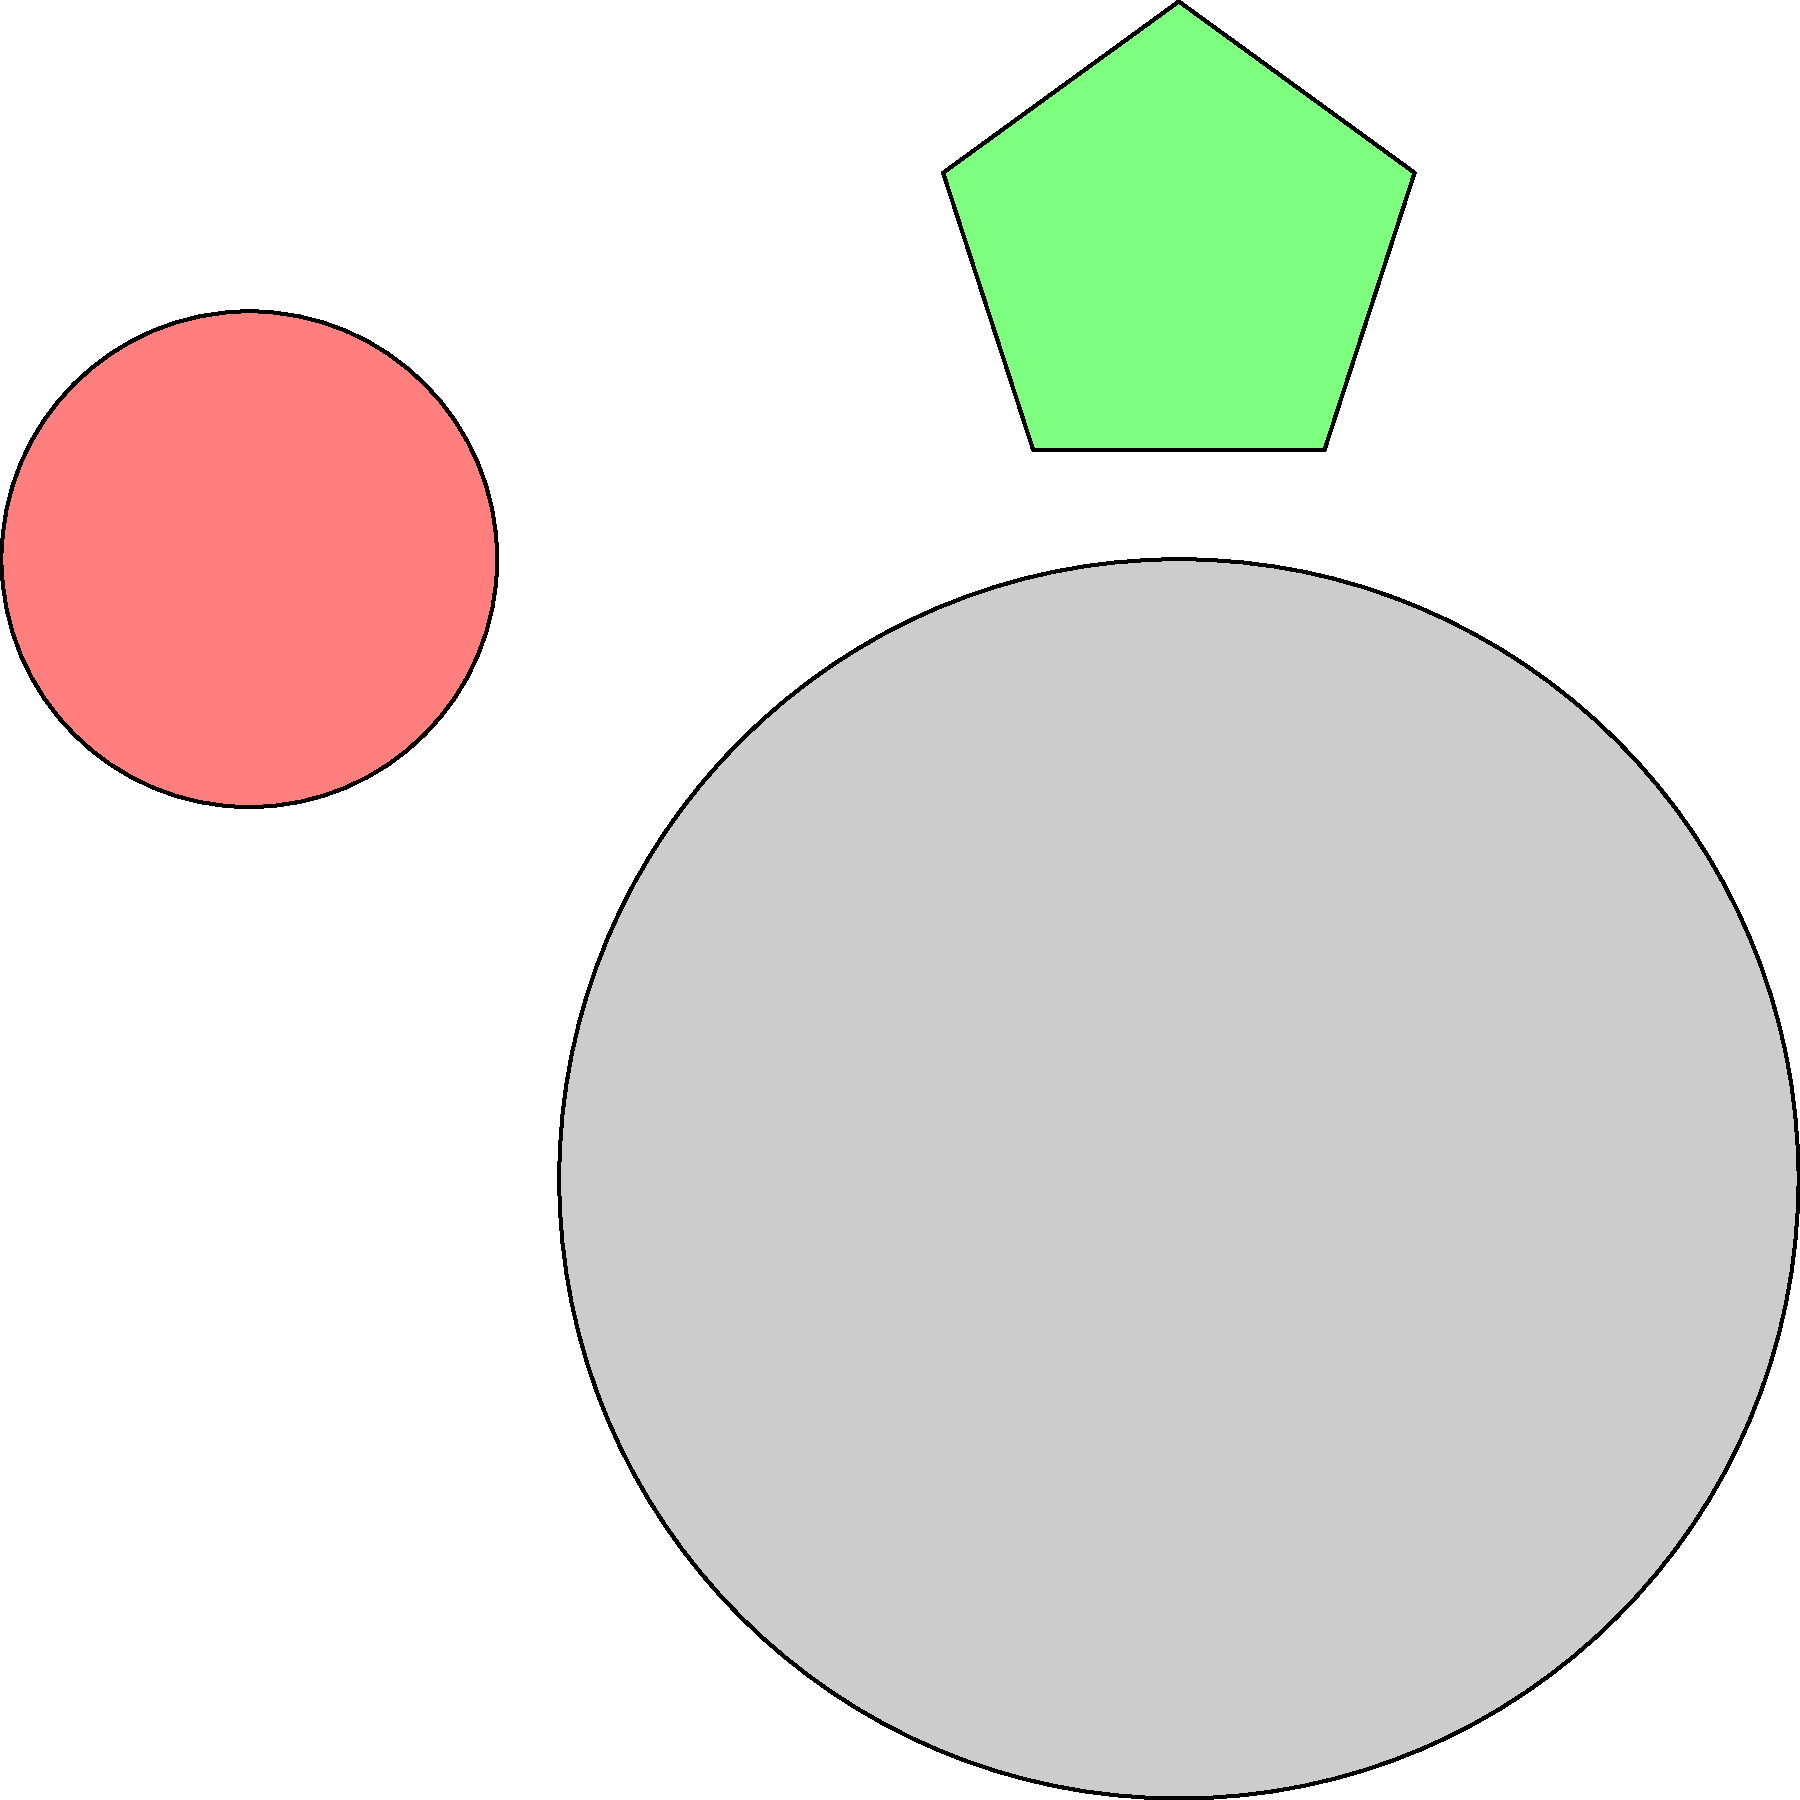As a professional digital designer, which logo variation best adheres to the principle of simplicity while maintaining brand recognition based on the original circular logo shown? To answer this question, we need to consider the principle of simplicity in logo design and how it relates to brand recognition. Let's analyze each variation:

1. Original logo: A simple circular shape, which serves as the base for brand recognition.

2. Variation A: A smaller circular shape, maintaining the original form but reduced in size.
   - Pros: Preserves the original shape, ensuring brand consistency.
   - Cons: Doesn't add any new elements or improvements to the design.

3. Variation B: A pentagon shape, introducing a new geometric form.
   - Pros: Adds visual interest and uniqueness.
   - Cons: Deviates significantly from the original circular shape, potentially reducing brand recognition.

4. Variation C: A square shape, another geometric variation.
   - Pros: Simple and clean design.
   - Cons: Like variation B, it strays from the original circular shape.

The principle of simplicity in logo design suggests that a logo should be easy to recognize and remember. It should also be versatile enough to work across various applications and sizes.

Considering these factors, Variation A best adheres to the principle of simplicity while maintaining brand recognition. It preserves the original circular shape, ensuring consistency with the established brand identity. The reduced size demonstrates versatility, allowing the logo to be used in various contexts without losing its essence.

While variations B and C introduce interesting geometric shapes, they deviate too much from the original design, potentially compromising brand recognition. In logo design, maintaining a connection to the original form is crucial for brand consistency and recall.
Answer: Variation A 